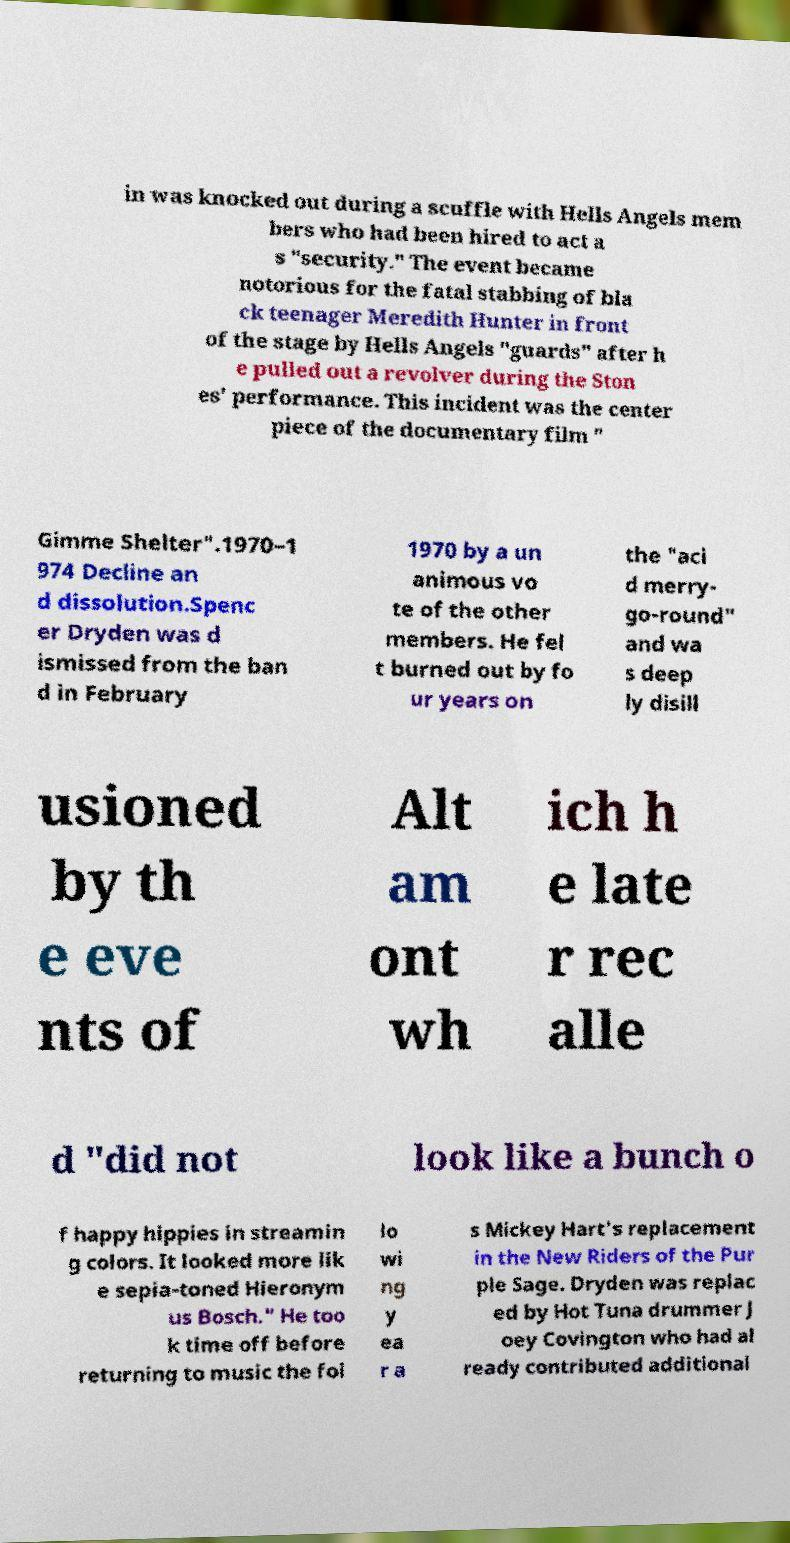There's text embedded in this image that I need extracted. Can you transcribe it verbatim? in was knocked out during a scuffle with Hells Angels mem bers who had been hired to act a s "security." The event became notorious for the fatal stabbing of bla ck teenager Meredith Hunter in front of the stage by Hells Angels "guards" after h e pulled out a revolver during the Ston es' performance. This incident was the center piece of the documentary film " Gimme Shelter".1970–1 974 Decline an d dissolution.Spenc er Dryden was d ismissed from the ban d in February 1970 by a un animous vo te of the other members. He fel t burned out by fo ur years on the "aci d merry- go-round" and wa s deep ly disill usioned by th e eve nts of Alt am ont wh ich h e late r rec alle d "did not look like a bunch o f happy hippies in streamin g colors. It looked more lik e sepia-toned Hieronym us Bosch." He too k time off before returning to music the fol lo wi ng y ea r a s Mickey Hart's replacement in the New Riders of the Pur ple Sage. Dryden was replac ed by Hot Tuna drummer J oey Covington who had al ready contributed additional 